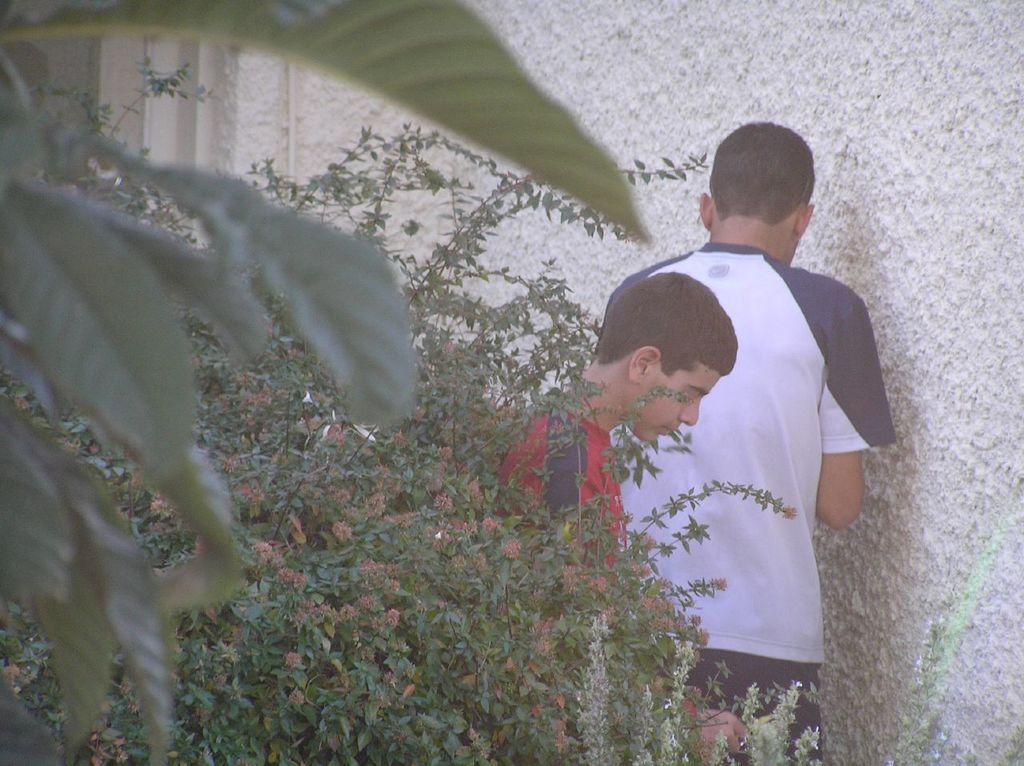How many people are in the image? There are two persons in the center of the image. What can be seen in the foreground of the image? There are plants in the foreground of the image. What is visible in the background of the image? There is a wall in the background of the image. What type of silk is being used to control the plants in the image? There is no silk or control mechanism present in the image; it features two persons and plants. 